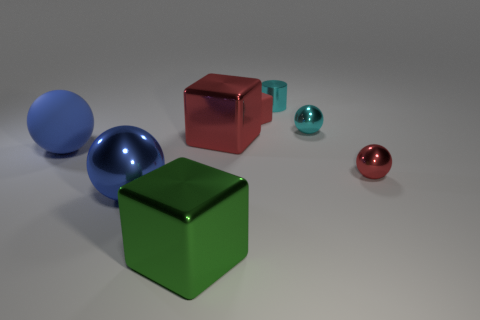Subtract all purple blocks. Subtract all brown cylinders. How many blocks are left? 3 Add 2 big metal objects. How many objects exist? 10 Subtract all cylinders. How many objects are left? 7 Add 7 big brown metal spheres. How many big brown metal spheres exist? 7 Subtract 0 brown balls. How many objects are left? 8 Subtract all small red blocks. Subtract all green metallic objects. How many objects are left? 6 Add 2 big green metal things. How many big green metal things are left? 3 